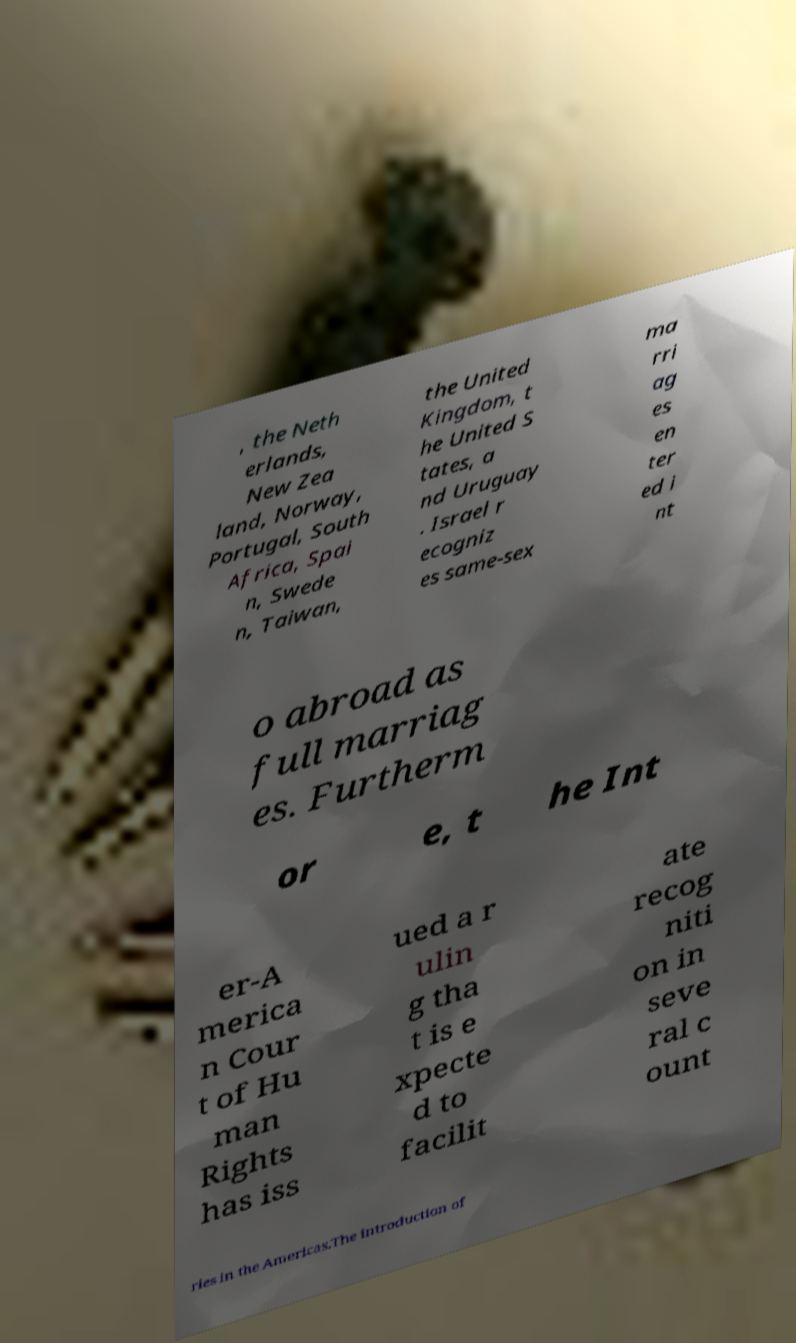Can you accurately transcribe the text from the provided image for me? , the Neth erlands, New Zea land, Norway, Portugal, South Africa, Spai n, Swede n, Taiwan, the United Kingdom, t he United S tates, a nd Uruguay . Israel r ecogniz es same-sex ma rri ag es en ter ed i nt o abroad as full marriag es. Furtherm or e, t he Int er-A merica n Cour t of Hu man Rights has iss ued a r ulin g tha t is e xpecte d to facilit ate recog niti on in seve ral c ount ries in the Americas.The introduction of 